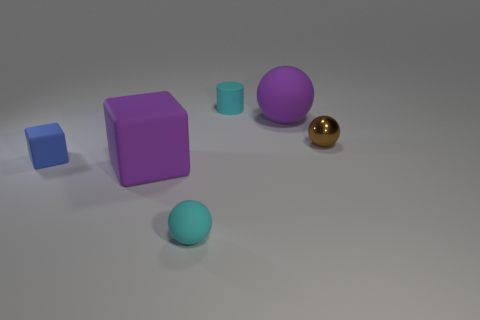Subtract all cyan rubber spheres. How many spheres are left? 2 Subtract 3 balls. How many balls are left? 0 Add 2 brown shiny spheres. How many objects exist? 8 Subtract all blue blocks. How many blocks are left? 1 Subtract all cylinders. How many objects are left? 5 Subtract all yellow cylinders. Subtract all gray spheres. How many cylinders are left? 1 Subtract all yellow spheres. How many purple cubes are left? 1 Subtract all brown objects. Subtract all small brown spheres. How many objects are left? 4 Add 1 tiny blocks. How many tiny blocks are left? 2 Add 5 tiny brown shiny things. How many tiny brown shiny things exist? 6 